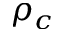Convert formula to latex. <formula><loc_0><loc_0><loc_500><loc_500>\rho _ { c }</formula> 